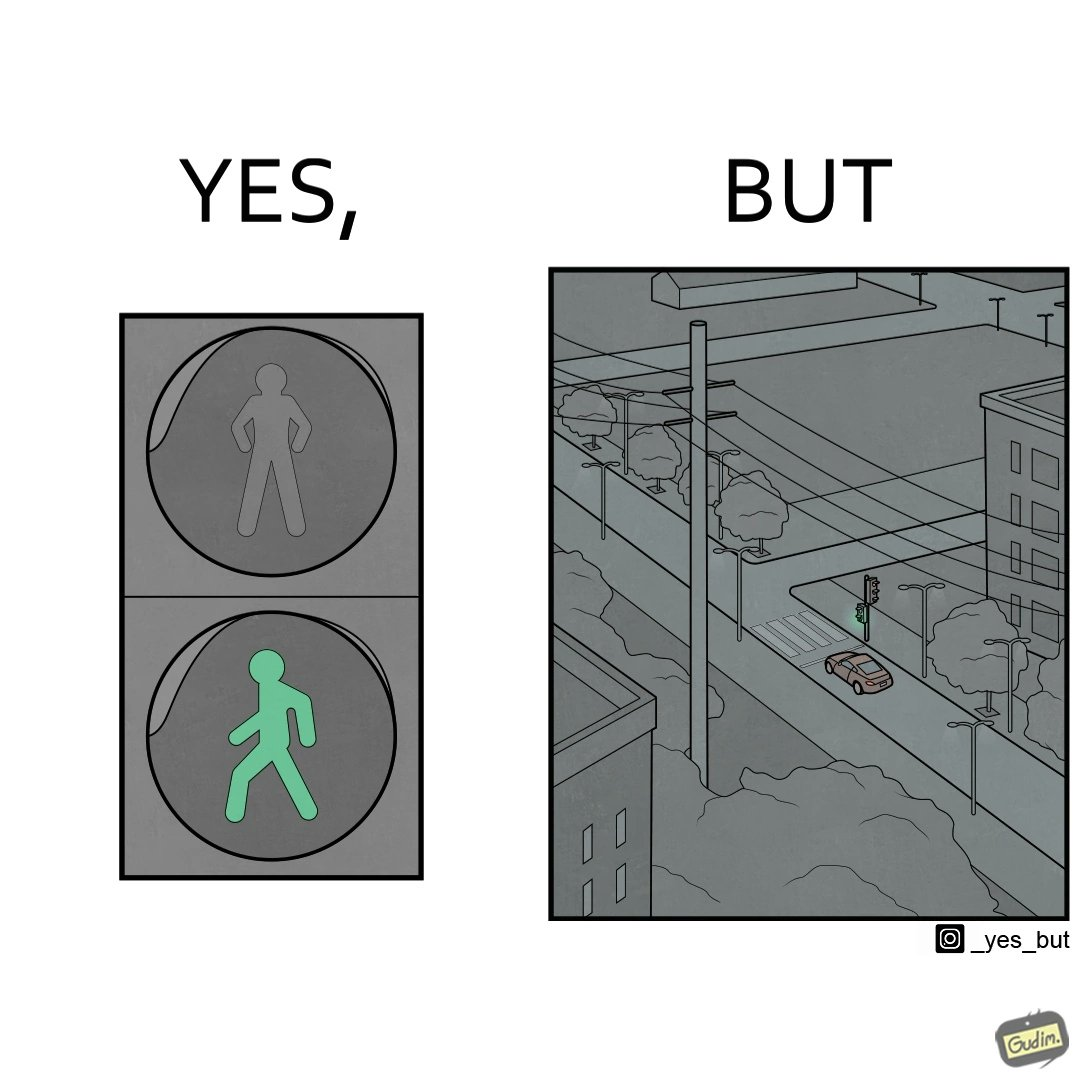Is this image satirical or non-satirical? Yes, this image is satirical. 